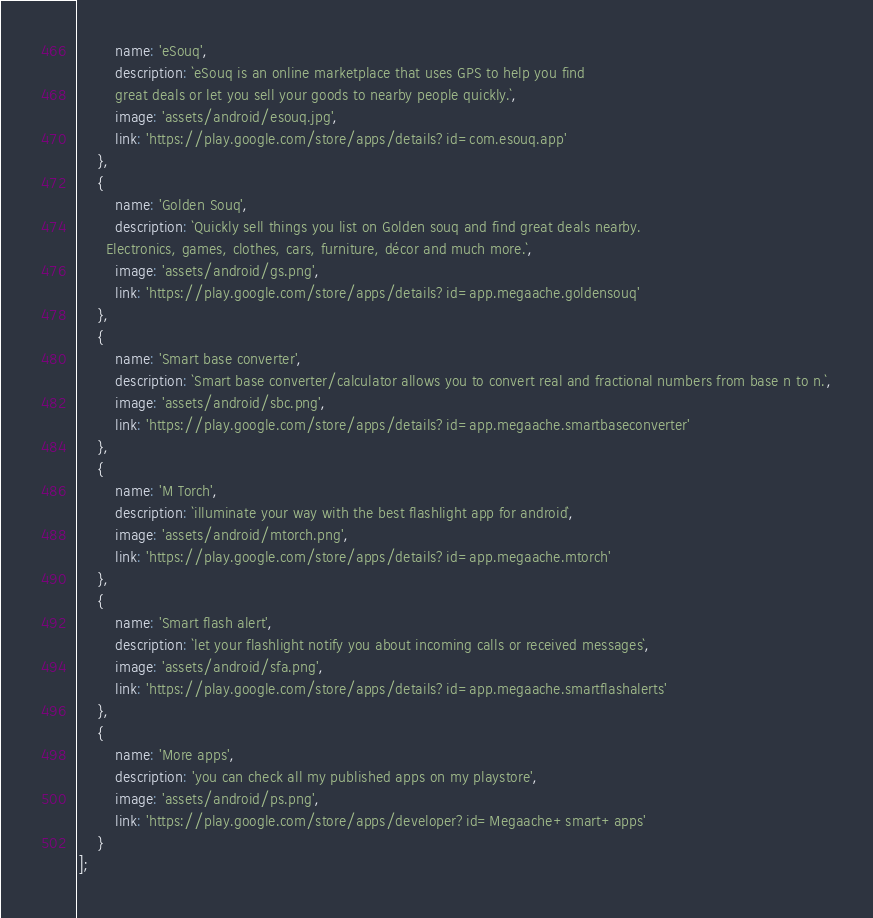<code> <loc_0><loc_0><loc_500><loc_500><_TypeScript_>        name: 'eSouq',
        description: `eSouq is an online marketplace that uses GPS to help you find
        great deals or let you sell your goods to nearby people quickly.`,
        image: 'assets/android/esouq.jpg',
        link: 'https://play.google.com/store/apps/details?id=com.esouq.app'
    },
    {
        name: 'Golden Souq',
        description: `Quickly sell things you list on Golden souq and find great deals nearby.
      Electronics, games, clothes, cars, furniture, décor and much more.`,
        image: 'assets/android/gs.png',
        link: 'https://play.google.com/store/apps/details?id=app.megaache.goldensouq'
    },
    {
        name: 'Smart base converter',
        description: `Smart base converter/calculator allows you to convert real and fractional numbers from base n to n.`,
        image: 'assets/android/sbc.png',
        link: 'https://play.google.com/store/apps/details?id=app.megaache.smartbaseconverter'
    },
    {
        name: 'M Torch',
        description: `illuminate your way with the best flashlight app for android`,
        image: 'assets/android/mtorch.png',
        link: 'https://play.google.com/store/apps/details?id=app.megaache.mtorch'
    },
    {
        name: 'Smart flash alert',
        description: `let your flashlight notify you about incoming calls or received messages`,
        image: 'assets/android/sfa.png',
        link: 'https://play.google.com/store/apps/details?id=app.megaache.smartflashalerts'
    },
    {
        name: 'More apps',
        description: 'you can check all my published apps on my playstore',
        image: 'assets/android/ps.png',
        link: 'https://play.google.com/store/apps/developer?id=Megaache+smart+apps'
    }
];
</code> 